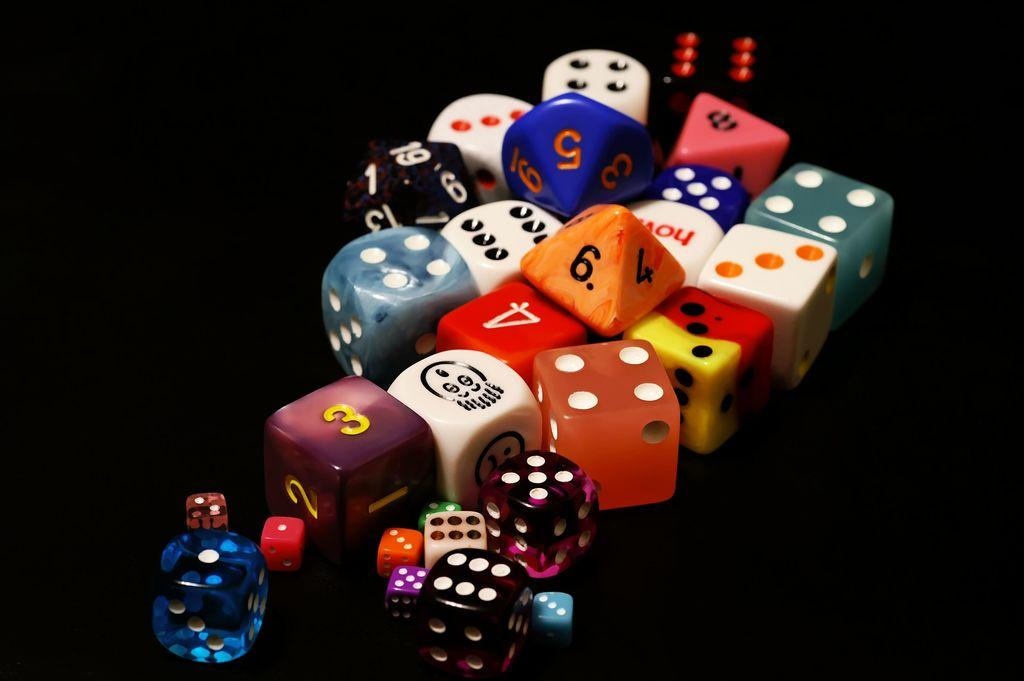What objects are present in the image? There are dice in the image. Can you describe the dice in the image? The dice come in different sizes. What is the color of the surface on which the dice are placed? The surface on which the dice are placed is black. How many cattle can be seen grazing in the image? There are no cattle present in the image; it features dice on a black surface. What type of bat is flying in the image? There are no bats present in the image; it features dice on a black surface. 